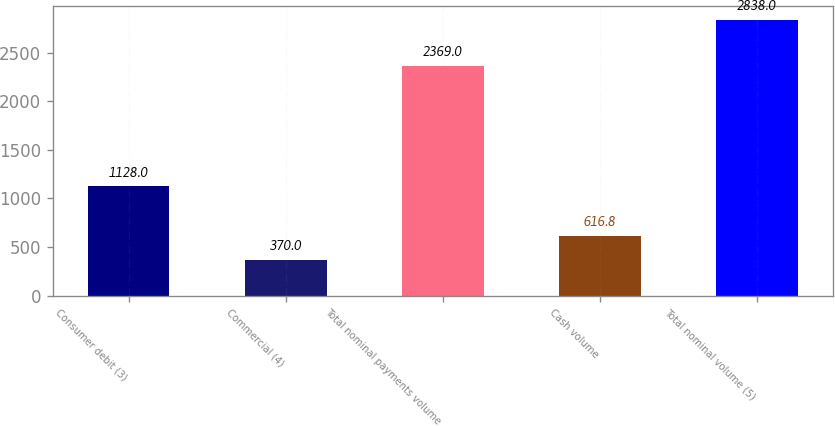<chart> <loc_0><loc_0><loc_500><loc_500><bar_chart><fcel>Consumer debit (3)<fcel>Commercial (4)<fcel>Total nominal payments volume<fcel>Cash volume<fcel>Total nominal volume (5)<nl><fcel>1128<fcel>370<fcel>2369<fcel>616.8<fcel>2838<nl></chart> 